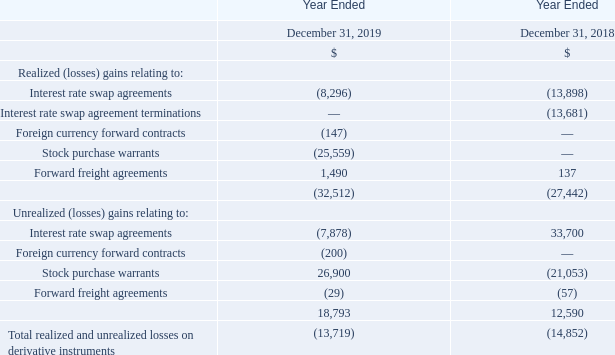Realized and unrealized (losses) gains on non-designated derivative instruments. Realized and unrealized (losses) gains related to derivative instruments that are not designated as hedges for accounting purposes are included as a separate line item in the consolidated statements of loss. Net realized and unrealized losses on non-designated derivatives were $13.7 million for 2019, compared to $14.9 million for 2018, as detailed in the table below:
The realized losses relate to amounts we actually realized for settlements related to these derivative instruments in normal course and amounts paid to terminate interest rate swap agreement terminations.
During 2019 and 2018, we had interest rate swap agreements with aggregate average net outstanding notional amounts of approximately $1.1 billion and $1.3 billion, respectively, with average fixed rates of approximately 3.0% and 2.9%, respectively. Short-term variable benchmark interest rates during these periods were generally less than 3.0% and, as such, we incurred realized losses of $8.3 million and $13.9 million during 2019 and 2018, respectively, under the interest rate swap agreements.
We did not incur any realized losses related to the termination of interest rate swaps in 2019, compared to realized losses of $13.7 million during 2018. Primarily as a result of significant changes in long-term benchmark interest rates during 2019 and 2018, we recognized unrealized losses of $7.9 million in 2019 compared to unrealized gains of $33.7 million in 2018 under the interest rate swap agreements.
During the year ended December 31, 2019, we recognized a reversal of previously unrealized losses of $26.9 million on all the warrants held by Teekay to purchase common units of Altera (or the Warrants) as a result of the sale of the Warrants to Brookfield, and we concurrently recognized a realized loss of $25.6 million during the same period. During the year ended December 31, 2018, we recognized unrealized losses of $21.1 million on the Warrants. Please read “Item 18 – Financial Statements: Note 12 – Fair Value Measurements and Financial Instruments.”
What was the Net realized and unrealized losses on non-designated derivatives in 2019? Net realized and unrealized losses on non-designated derivatives were $13.7 million for 2019. What was the Net realized and unrealized losses on non-designated derivatives in 2018? $14.9 million for 2018. How much was the interest rate swap agreements with aggregate average net outstanding notional amounts during 2019 and 2018? During 2019 and 2018, we had interest rate swap agreements with aggregate average net outstanding notional amounts of approximately $1.1 billion and $1.3 billion, respectively. What is the increase/ (decrease) in Realized (losses) gains relating to Interest rate swap agreements from Year Ended December 31, 2019 to December 31, 2018?
Answer scale should be: million. 8,296-13,898
Answer: -5602. What is the increase/ (decrease) in Realized (losses) gains relating to Forward freight agreements from Year Ended December 31, 2019 to December 31, 2018?
Answer scale should be: million. 1,490-137
Answer: 1353. What is the increase/ (decrease) in Unrealized (losses) gains relating to Interest rate swap agreements from Year Ended December 31, 2019 to December 31, 2018?
Answer scale should be: million. 7,878-33,700
Answer: -25822. 